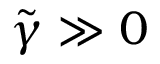Convert formula to latex. <formula><loc_0><loc_0><loc_500><loc_500>\tilde { \gamma } \gg 0</formula> 